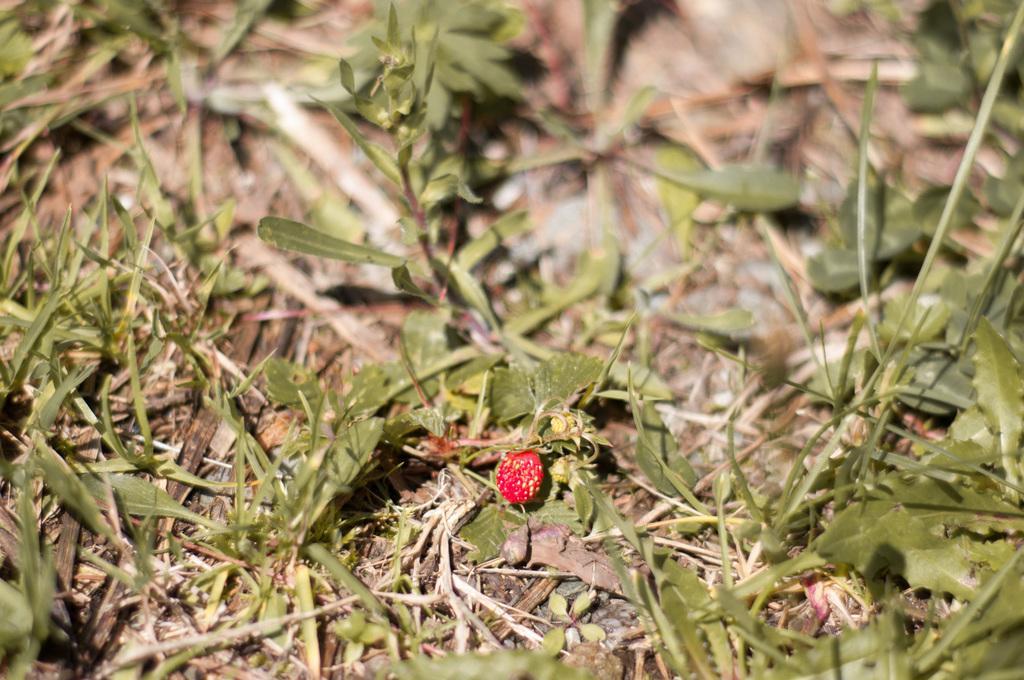Can you describe this image briefly? In this picture I can observe red color fruit. I can observe some plants and grass on the ground. The background is blurred. 